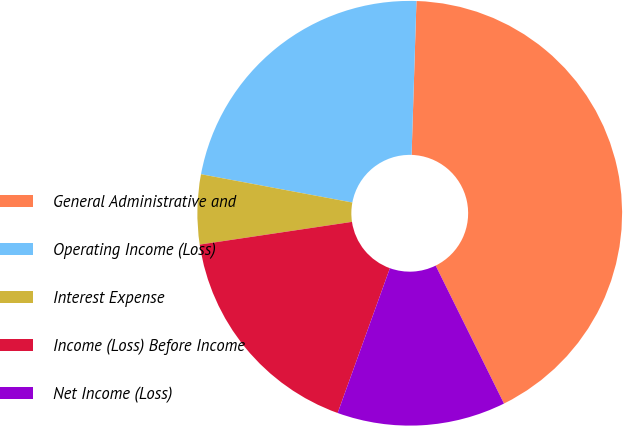<chart> <loc_0><loc_0><loc_500><loc_500><pie_chart><fcel>General Administrative and<fcel>Operating Income (Loss)<fcel>Interest Expense<fcel>Income (Loss) Before Income<fcel>Net Income (Loss)<nl><fcel>42.18%<fcel>22.56%<fcel>5.3%<fcel>17.13%<fcel>12.83%<nl></chart> 